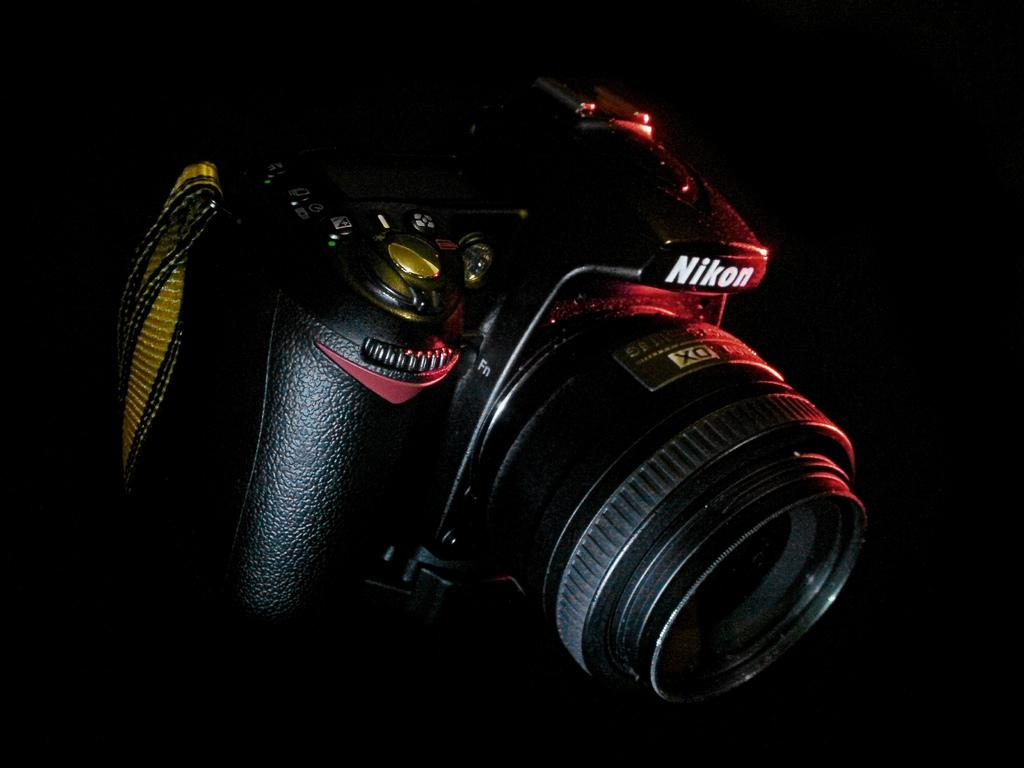What is the main subject of the image? The main subject of the image is a camera. Can you describe the background of the image? The background of the image is dark. What is the mind of the camera doing in the image? The concept of a camera having a mind is not applicable, as cameras are inanimate objects and do not possess cognitive abilities. 